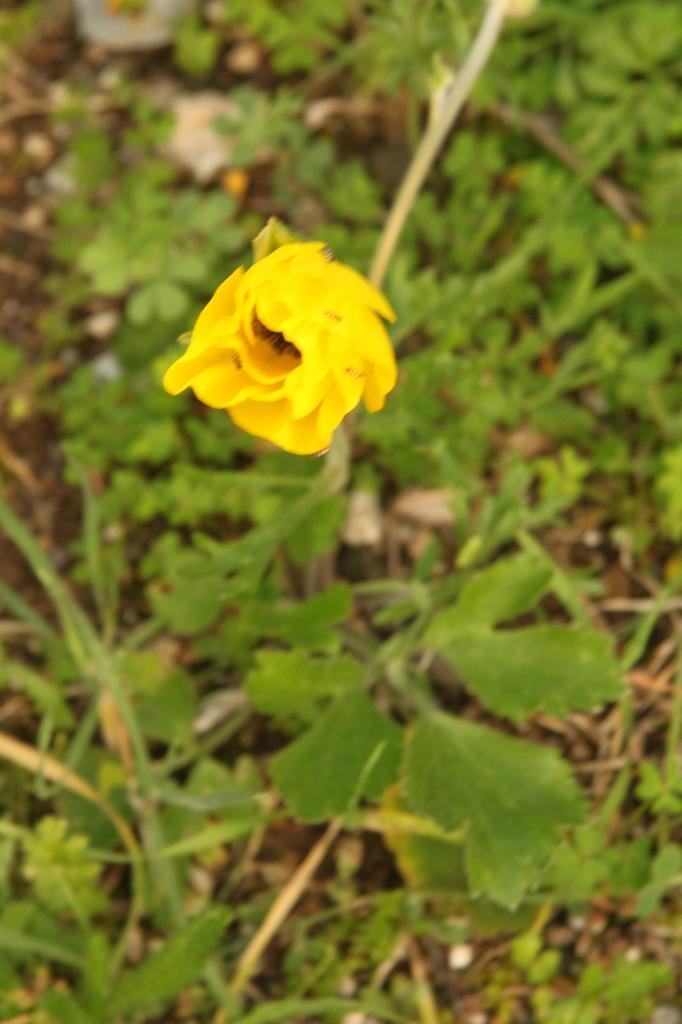What is the main subject of the image? There is a flower in the center of the image. What color is the flower? The flower is yellow. What can be seen in the background of the image? There are plants in the background of the image. How many butterflies are sitting on the flower in the image? There are no butterflies present in the image; it only features a yellow flower and plants in the background. What type of stitch is used to create the flower in the image? The image is not a drawing or embroidery, so there is no stitch used to create the flower. 